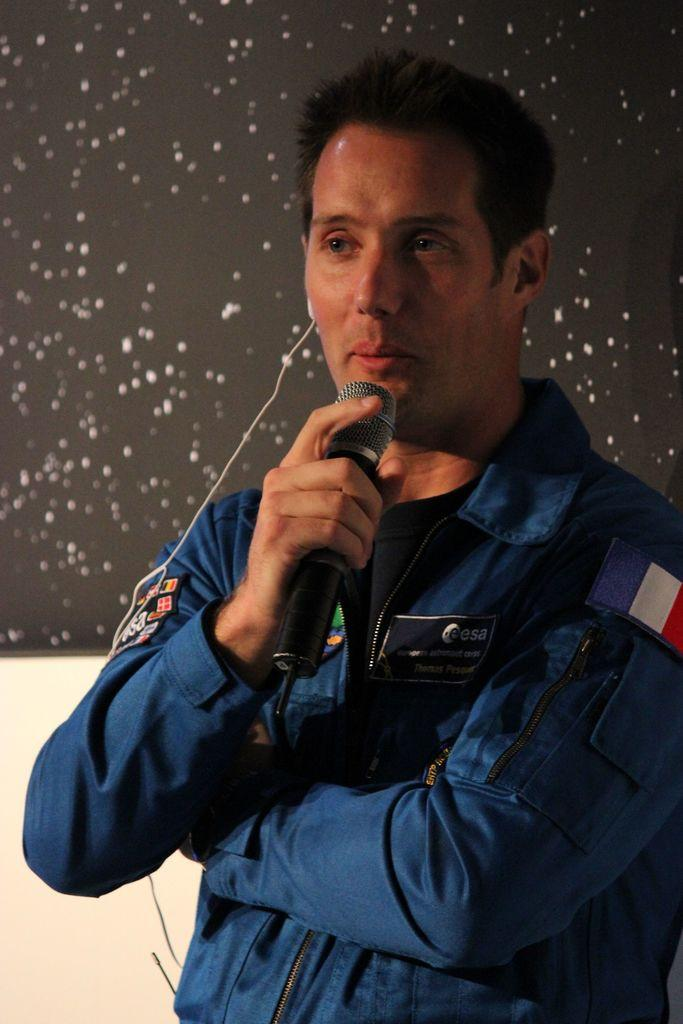What color is the jacket that the person is wearing in the image? The person is wearing a blue jacket. What is the person holding in their right hand? The person is holding a microphone in their right hand. What is the person doing in the image? The person is speaking. How is the person able to hear themselves or others while speaking? The person has an earphone in their right ear. What is the color and pattern of the background in the image? The background is black with white spots. How many balls are visible in the image? There are no balls visible in the image. What is the weight of the person in the image? The weight of the person cannot be determined from the image. 